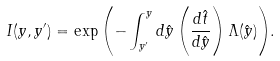<formula> <loc_0><loc_0><loc_500><loc_500>I ( y , y ^ { \prime } ) = \exp { \left ( - \int _ { y ^ { \prime } } ^ { y } d \hat { y } \left ( \frac { d \hat { t } } { d \hat { y } } \right ) \Lambda ( \hat { y } ) \right ) } .</formula> 